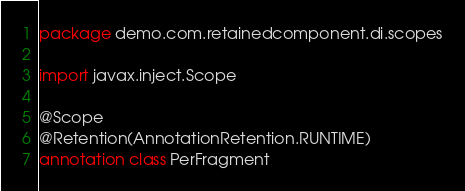Convert code to text. <code><loc_0><loc_0><loc_500><loc_500><_Kotlin_>package demo.com.retainedcomponent.di.scopes

import javax.inject.Scope

@Scope
@Retention(AnnotationRetention.RUNTIME)
annotation class PerFragment</code> 